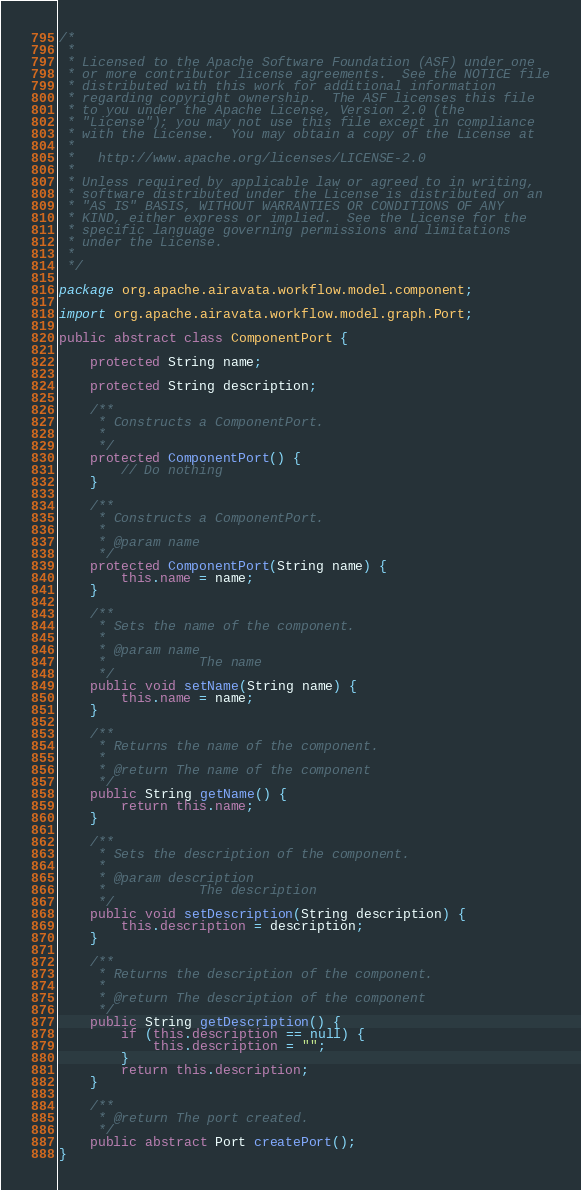Convert code to text. <code><loc_0><loc_0><loc_500><loc_500><_Java_>/*
 *
 * Licensed to the Apache Software Foundation (ASF) under one
 * or more contributor license agreements.  See the NOTICE file
 * distributed with this work for additional information
 * regarding copyright ownership.  The ASF licenses this file
 * to you under the Apache License, Version 2.0 (the
 * "License"); you may not use this file except in compliance
 * with the License.  You may obtain a copy of the License at
 *
 *   http://www.apache.org/licenses/LICENSE-2.0
 *
 * Unless required by applicable law or agreed to in writing,
 * software distributed under the License is distributed on an
 * "AS IS" BASIS, WITHOUT WARRANTIES OR CONDITIONS OF ANY
 * KIND, either express or implied.  See the License for the
 * specific language governing permissions and limitations
 * under the License.
 *
 */

package org.apache.airavata.workflow.model.component;

import org.apache.airavata.workflow.model.graph.Port;

public abstract class ComponentPort {

    protected String name;

    protected String description;

    /**
     * Constructs a ComponentPort.
     * 
     */
    protected ComponentPort() {
        // Do nothing
    }

    /**
     * Constructs a ComponentPort.
     * 
     * @param name
     */
    protected ComponentPort(String name) {
        this.name = name;
    }

    /**
     * Sets the name of the component.
     * 
     * @param name
     *            The name
     */
    public void setName(String name) {
        this.name = name;
    }

    /**
     * Returns the name of the component.
     * 
     * @return The name of the component
     */
    public String getName() {
        return this.name;
    }

    /**
     * Sets the description of the component.
     * 
     * @param description
     *            The description
     */
    public void setDescription(String description) {
        this.description = description;
    }

    /**
     * Returns the description of the component.
     * 
     * @return The description of the component
     */
    public String getDescription() {
        if (this.description == null) {
            this.description = "";
        }
        return this.description;
    }

    /**
     * @return The port created.
     */
    public abstract Port createPort();
}</code> 